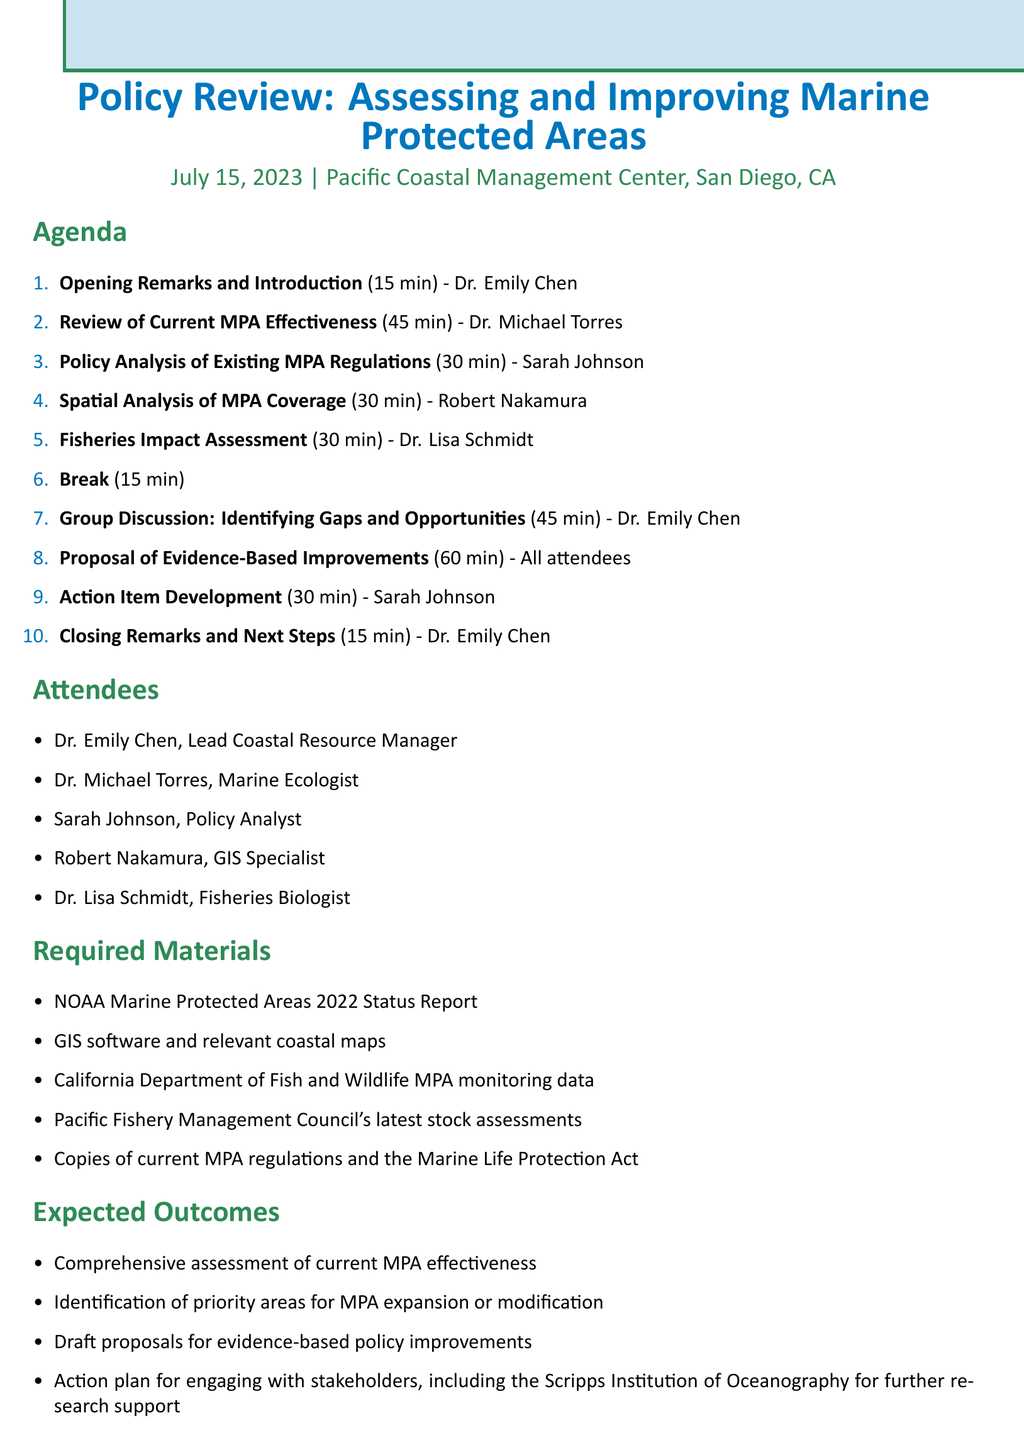what is the date of the meeting? The date of the meeting is specified at the beginning of the document.
Answer: July 15, 2023 who is the lead facilitator for the Group Discussion? The document specifies that Dr. Emily Chen facilitates this session.
Answer: Dr. Emily Chen how long is the presentation on MPA effectiveness? The duration of this agenda item is mentioned, which is the time allotted for the presentation.
Answer: 45 minutes what materials are required for the meeting? The document lists the necessary materials needed for the attendees during the meeting.
Answer: NOAA Marine Protected Areas 2022 Status Report who will present the Fisheries Impact Assessment? The name of the individual presenting this assessment can be found in the agenda item details.
Answer: Dr. Lisa Schmidt what is one expected outcome of the meeting? The document outlines several expected outcomes for this meeting, which can be found in the respective section.
Answer: Comprehensive assessment of current MPA effectiveness how many attendees are listed in the document? The number of attendees is indicated in the attendees section of the document.
Answer: 5 which organization is mentioned for further research support engagement? The expected outcomes section refers to a specific institution related to research support.
Answer: Scripps Institution of Oceanography what is the duration of the Action Item Development? The document specifies the time allocated for this part of the agenda.
Answer: 30 minutes 